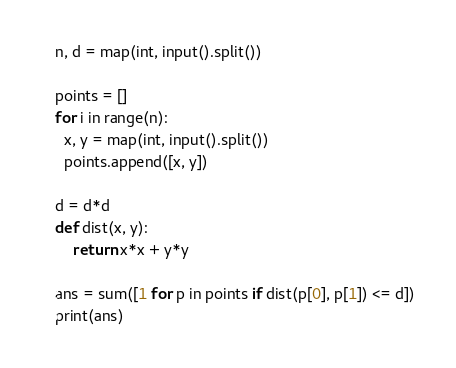Convert code to text. <code><loc_0><loc_0><loc_500><loc_500><_Python_>n, d = map(int, input().split())

points = []
for i in range(n):
  x, y = map(int, input().split())
  points.append([x, y])

d = d*d
def dist(x, y):
    return x*x + y*y

ans = sum([1 for p in points if dist(p[0], p[1]) <= d])
print(ans)</code> 